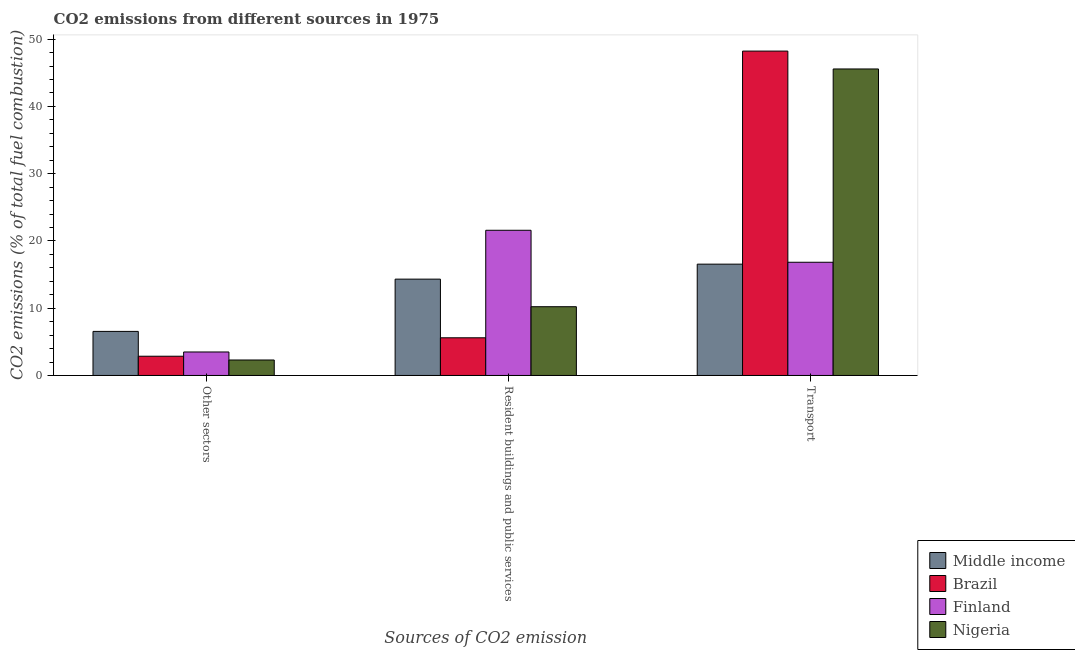How many groups of bars are there?
Provide a succinct answer. 3. How many bars are there on the 2nd tick from the left?
Provide a short and direct response. 4. What is the label of the 2nd group of bars from the left?
Provide a short and direct response. Resident buildings and public services. What is the percentage of co2 emissions from other sectors in Nigeria?
Offer a very short reply. 2.3. Across all countries, what is the maximum percentage of co2 emissions from other sectors?
Your answer should be very brief. 6.55. Across all countries, what is the minimum percentage of co2 emissions from resident buildings and public services?
Provide a succinct answer. 5.6. In which country was the percentage of co2 emissions from transport maximum?
Offer a very short reply. Brazil. In which country was the percentage of co2 emissions from transport minimum?
Your answer should be compact. Middle income. What is the total percentage of co2 emissions from transport in the graph?
Offer a very short reply. 127.18. What is the difference between the percentage of co2 emissions from transport in Finland and that in Nigeria?
Make the answer very short. -28.74. What is the difference between the percentage of co2 emissions from resident buildings and public services in Nigeria and the percentage of co2 emissions from transport in Middle income?
Keep it short and to the point. -6.33. What is the average percentage of co2 emissions from resident buildings and public services per country?
Provide a succinct answer. 12.93. What is the difference between the percentage of co2 emissions from other sectors and percentage of co2 emissions from resident buildings and public services in Middle income?
Your answer should be compact. -7.77. In how many countries, is the percentage of co2 emissions from other sectors greater than 8 %?
Offer a very short reply. 0. What is the ratio of the percentage of co2 emissions from transport in Middle income to that in Brazil?
Offer a very short reply. 0.34. Is the percentage of co2 emissions from resident buildings and public services in Brazil less than that in Nigeria?
Ensure brevity in your answer.  Yes. Is the difference between the percentage of co2 emissions from resident buildings and public services in Middle income and Nigeria greater than the difference between the percentage of co2 emissions from other sectors in Middle income and Nigeria?
Keep it short and to the point. No. What is the difference between the highest and the second highest percentage of co2 emissions from other sectors?
Give a very brief answer. 3.06. What is the difference between the highest and the lowest percentage of co2 emissions from other sectors?
Give a very brief answer. 4.25. In how many countries, is the percentage of co2 emissions from transport greater than the average percentage of co2 emissions from transport taken over all countries?
Make the answer very short. 2. Is the sum of the percentage of co2 emissions from transport in Middle income and Nigeria greater than the maximum percentage of co2 emissions from resident buildings and public services across all countries?
Give a very brief answer. Yes. What does the 4th bar from the left in Resident buildings and public services represents?
Your answer should be very brief. Nigeria. Is it the case that in every country, the sum of the percentage of co2 emissions from other sectors and percentage of co2 emissions from resident buildings and public services is greater than the percentage of co2 emissions from transport?
Your answer should be very brief. No. How many countries are there in the graph?
Keep it short and to the point. 4. What is the difference between two consecutive major ticks on the Y-axis?
Your answer should be very brief. 10. Does the graph contain any zero values?
Your response must be concise. No. Where does the legend appear in the graph?
Provide a short and direct response. Bottom right. How many legend labels are there?
Your response must be concise. 4. What is the title of the graph?
Ensure brevity in your answer.  CO2 emissions from different sources in 1975. Does "Rwanda" appear as one of the legend labels in the graph?
Offer a very short reply. No. What is the label or title of the X-axis?
Your answer should be very brief. Sources of CO2 emission. What is the label or title of the Y-axis?
Make the answer very short. CO2 emissions (% of total fuel combustion). What is the CO2 emissions (% of total fuel combustion) in Middle income in Other sectors?
Offer a very short reply. 6.55. What is the CO2 emissions (% of total fuel combustion) in Brazil in Other sectors?
Make the answer very short. 2.86. What is the CO2 emissions (% of total fuel combustion) in Finland in Other sectors?
Make the answer very short. 3.49. What is the CO2 emissions (% of total fuel combustion) in Nigeria in Other sectors?
Provide a short and direct response. 2.3. What is the CO2 emissions (% of total fuel combustion) in Middle income in Resident buildings and public services?
Ensure brevity in your answer.  14.32. What is the CO2 emissions (% of total fuel combustion) in Brazil in Resident buildings and public services?
Your answer should be very brief. 5.6. What is the CO2 emissions (% of total fuel combustion) of Finland in Resident buildings and public services?
Keep it short and to the point. 21.59. What is the CO2 emissions (% of total fuel combustion) of Nigeria in Resident buildings and public services?
Provide a succinct answer. 10.22. What is the CO2 emissions (% of total fuel combustion) of Middle income in Transport?
Ensure brevity in your answer.  16.55. What is the CO2 emissions (% of total fuel combustion) in Brazil in Transport?
Your answer should be compact. 48.23. What is the CO2 emissions (% of total fuel combustion) in Finland in Transport?
Keep it short and to the point. 16.83. What is the CO2 emissions (% of total fuel combustion) of Nigeria in Transport?
Your answer should be compact. 45.57. Across all Sources of CO2 emission, what is the maximum CO2 emissions (% of total fuel combustion) of Middle income?
Give a very brief answer. 16.55. Across all Sources of CO2 emission, what is the maximum CO2 emissions (% of total fuel combustion) in Brazil?
Your answer should be compact. 48.23. Across all Sources of CO2 emission, what is the maximum CO2 emissions (% of total fuel combustion) in Finland?
Offer a very short reply. 21.59. Across all Sources of CO2 emission, what is the maximum CO2 emissions (% of total fuel combustion) of Nigeria?
Give a very brief answer. 45.57. Across all Sources of CO2 emission, what is the minimum CO2 emissions (% of total fuel combustion) of Middle income?
Your response must be concise. 6.55. Across all Sources of CO2 emission, what is the minimum CO2 emissions (% of total fuel combustion) in Brazil?
Keep it short and to the point. 2.86. Across all Sources of CO2 emission, what is the minimum CO2 emissions (% of total fuel combustion) in Finland?
Ensure brevity in your answer.  3.49. Across all Sources of CO2 emission, what is the minimum CO2 emissions (% of total fuel combustion) of Nigeria?
Your answer should be very brief. 2.3. What is the total CO2 emissions (% of total fuel combustion) in Middle income in the graph?
Provide a short and direct response. 37.42. What is the total CO2 emissions (% of total fuel combustion) of Brazil in the graph?
Ensure brevity in your answer.  56.69. What is the total CO2 emissions (% of total fuel combustion) of Finland in the graph?
Offer a very short reply. 41.91. What is the total CO2 emissions (% of total fuel combustion) of Nigeria in the graph?
Provide a succinct answer. 58.09. What is the difference between the CO2 emissions (% of total fuel combustion) in Middle income in Other sectors and that in Resident buildings and public services?
Keep it short and to the point. -7.77. What is the difference between the CO2 emissions (% of total fuel combustion) in Brazil in Other sectors and that in Resident buildings and public services?
Make the answer very short. -2.74. What is the difference between the CO2 emissions (% of total fuel combustion) of Finland in Other sectors and that in Resident buildings and public services?
Keep it short and to the point. -18.09. What is the difference between the CO2 emissions (% of total fuel combustion) of Nigeria in Other sectors and that in Resident buildings and public services?
Your answer should be compact. -7.92. What is the difference between the CO2 emissions (% of total fuel combustion) of Middle income in Other sectors and that in Transport?
Offer a terse response. -10. What is the difference between the CO2 emissions (% of total fuel combustion) in Brazil in Other sectors and that in Transport?
Offer a terse response. -45.37. What is the difference between the CO2 emissions (% of total fuel combustion) of Finland in Other sectors and that in Transport?
Your answer should be very brief. -13.34. What is the difference between the CO2 emissions (% of total fuel combustion) in Nigeria in Other sectors and that in Transport?
Provide a short and direct response. -43.27. What is the difference between the CO2 emissions (% of total fuel combustion) in Middle income in Resident buildings and public services and that in Transport?
Keep it short and to the point. -2.23. What is the difference between the CO2 emissions (% of total fuel combustion) in Brazil in Resident buildings and public services and that in Transport?
Provide a short and direct response. -42.63. What is the difference between the CO2 emissions (% of total fuel combustion) of Finland in Resident buildings and public services and that in Transport?
Give a very brief answer. 4.75. What is the difference between the CO2 emissions (% of total fuel combustion) of Nigeria in Resident buildings and public services and that in Transport?
Keep it short and to the point. -35.35. What is the difference between the CO2 emissions (% of total fuel combustion) of Middle income in Other sectors and the CO2 emissions (% of total fuel combustion) of Brazil in Resident buildings and public services?
Make the answer very short. 0.95. What is the difference between the CO2 emissions (% of total fuel combustion) of Middle income in Other sectors and the CO2 emissions (% of total fuel combustion) of Finland in Resident buildings and public services?
Provide a succinct answer. -15.04. What is the difference between the CO2 emissions (% of total fuel combustion) in Middle income in Other sectors and the CO2 emissions (% of total fuel combustion) in Nigeria in Resident buildings and public services?
Give a very brief answer. -3.67. What is the difference between the CO2 emissions (% of total fuel combustion) in Brazil in Other sectors and the CO2 emissions (% of total fuel combustion) in Finland in Resident buildings and public services?
Your answer should be compact. -18.73. What is the difference between the CO2 emissions (% of total fuel combustion) of Brazil in Other sectors and the CO2 emissions (% of total fuel combustion) of Nigeria in Resident buildings and public services?
Your answer should be very brief. -7.36. What is the difference between the CO2 emissions (% of total fuel combustion) of Finland in Other sectors and the CO2 emissions (% of total fuel combustion) of Nigeria in Resident buildings and public services?
Provide a succinct answer. -6.73. What is the difference between the CO2 emissions (% of total fuel combustion) in Middle income in Other sectors and the CO2 emissions (% of total fuel combustion) in Brazil in Transport?
Your answer should be compact. -41.68. What is the difference between the CO2 emissions (% of total fuel combustion) of Middle income in Other sectors and the CO2 emissions (% of total fuel combustion) of Finland in Transport?
Offer a very short reply. -10.28. What is the difference between the CO2 emissions (% of total fuel combustion) in Middle income in Other sectors and the CO2 emissions (% of total fuel combustion) in Nigeria in Transport?
Keep it short and to the point. -39.02. What is the difference between the CO2 emissions (% of total fuel combustion) of Brazil in Other sectors and the CO2 emissions (% of total fuel combustion) of Finland in Transport?
Ensure brevity in your answer.  -13.97. What is the difference between the CO2 emissions (% of total fuel combustion) in Brazil in Other sectors and the CO2 emissions (% of total fuel combustion) in Nigeria in Transport?
Your answer should be very brief. -42.71. What is the difference between the CO2 emissions (% of total fuel combustion) in Finland in Other sectors and the CO2 emissions (% of total fuel combustion) in Nigeria in Transport?
Make the answer very short. -42.08. What is the difference between the CO2 emissions (% of total fuel combustion) of Middle income in Resident buildings and public services and the CO2 emissions (% of total fuel combustion) of Brazil in Transport?
Your answer should be compact. -33.9. What is the difference between the CO2 emissions (% of total fuel combustion) of Middle income in Resident buildings and public services and the CO2 emissions (% of total fuel combustion) of Finland in Transport?
Your response must be concise. -2.51. What is the difference between the CO2 emissions (% of total fuel combustion) of Middle income in Resident buildings and public services and the CO2 emissions (% of total fuel combustion) of Nigeria in Transport?
Provide a short and direct response. -31.25. What is the difference between the CO2 emissions (% of total fuel combustion) in Brazil in Resident buildings and public services and the CO2 emissions (% of total fuel combustion) in Finland in Transport?
Ensure brevity in your answer.  -11.23. What is the difference between the CO2 emissions (% of total fuel combustion) in Brazil in Resident buildings and public services and the CO2 emissions (% of total fuel combustion) in Nigeria in Transport?
Your answer should be very brief. -39.97. What is the difference between the CO2 emissions (% of total fuel combustion) of Finland in Resident buildings and public services and the CO2 emissions (% of total fuel combustion) of Nigeria in Transport?
Give a very brief answer. -23.98. What is the average CO2 emissions (% of total fuel combustion) of Middle income per Sources of CO2 emission?
Your answer should be very brief. 12.47. What is the average CO2 emissions (% of total fuel combustion) in Brazil per Sources of CO2 emission?
Offer a terse response. 18.9. What is the average CO2 emissions (% of total fuel combustion) of Finland per Sources of CO2 emission?
Provide a short and direct response. 13.97. What is the average CO2 emissions (% of total fuel combustion) of Nigeria per Sources of CO2 emission?
Make the answer very short. 19.36. What is the difference between the CO2 emissions (% of total fuel combustion) in Middle income and CO2 emissions (% of total fuel combustion) in Brazil in Other sectors?
Ensure brevity in your answer.  3.69. What is the difference between the CO2 emissions (% of total fuel combustion) of Middle income and CO2 emissions (% of total fuel combustion) of Finland in Other sectors?
Keep it short and to the point. 3.06. What is the difference between the CO2 emissions (% of total fuel combustion) of Middle income and CO2 emissions (% of total fuel combustion) of Nigeria in Other sectors?
Your answer should be compact. 4.25. What is the difference between the CO2 emissions (% of total fuel combustion) in Brazil and CO2 emissions (% of total fuel combustion) in Finland in Other sectors?
Your response must be concise. -0.63. What is the difference between the CO2 emissions (% of total fuel combustion) of Brazil and CO2 emissions (% of total fuel combustion) of Nigeria in Other sectors?
Offer a very short reply. 0.56. What is the difference between the CO2 emissions (% of total fuel combustion) in Finland and CO2 emissions (% of total fuel combustion) in Nigeria in Other sectors?
Ensure brevity in your answer.  1.19. What is the difference between the CO2 emissions (% of total fuel combustion) in Middle income and CO2 emissions (% of total fuel combustion) in Brazil in Resident buildings and public services?
Ensure brevity in your answer.  8.72. What is the difference between the CO2 emissions (% of total fuel combustion) of Middle income and CO2 emissions (% of total fuel combustion) of Finland in Resident buildings and public services?
Offer a very short reply. -7.26. What is the difference between the CO2 emissions (% of total fuel combustion) in Middle income and CO2 emissions (% of total fuel combustion) in Nigeria in Resident buildings and public services?
Your answer should be compact. 4.1. What is the difference between the CO2 emissions (% of total fuel combustion) in Brazil and CO2 emissions (% of total fuel combustion) in Finland in Resident buildings and public services?
Offer a terse response. -15.98. What is the difference between the CO2 emissions (% of total fuel combustion) of Brazil and CO2 emissions (% of total fuel combustion) of Nigeria in Resident buildings and public services?
Make the answer very short. -4.62. What is the difference between the CO2 emissions (% of total fuel combustion) of Finland and CO2 emissions (% of total fuel combustion) of Nigeria in Resident buildings and public services?
Keep it short and to the point. 11.36. What is the difference between the CO2 emissions (% of total fuel combustion) of Middle income and CO2 emissions (% of total fuel combustion) of Brazil in Transport?
Offer a very short reply. -31.68. What is the difference between the CO2 emissions (% of total fuel combustion) of Middle income and CO2 emissions (% of total fuel combustion) of Finland in Transport?
Your answer should be compact. -0.28. What is the difference between the CO2 emissions (% of total fuel combustion) of Middle income and CO2 emissions (% of total fuel combustion) of Nigeria in Transport?
Offer a terse response. -29.02. What is the difference between the CO2 emissions (% of total fuel combustion) of Brazil and CO2 emissions (% of total fuel combustion) of Finland in Transport?
Your answer should be compact. 31.4. What is the difference between the CO2 emissions (% of total fuel combustion) in Brazil and CO2 emissions (% of total fuel combustion) in Nigeria in Transport?
Provide a succinct answer. 2.66. What is the difference between the CO2 emissions (% of total fuel combustion) in Finland and CO2 emissions (% of total fuel combustion) in Nigeria in Transport?
Keep it short and to the point. -28.74. What is the ratio of the CO2 emissions (% of total fuel combustion) in Middle income in Other sectors to that in Resident buildings and public services?
Your answer should be very brief. 0.46. What is the ratio of the CO2 emissions (% of total fuel combustion) of Brazil in Other sectors to that in Resident buildings and public services?
Offer a terse response. 0.51. What is the ratio of the CO2 emissions (% of total fuel combustion) in Finland in Other sectors to that in Resident buildings and public services?
Ensure brevity in your answer.  0.16. What is the ratio of the CO2 emissions (% of total fuel combustion) of Nigeria in Other sectors to that in Resident buildings and public services?
Provide a succinct answer. 0.23. What is the ratio of the CO2 emissions (% of total fuel combustion) of Middle income in Other sectors to that in Transport?
Provide a short and direct response. 0.4. What is the ratio of the CO2 emissions (% of total fuel combustion) of Brazil in Other sectors to that in Transport?
Give a very brief answer. 0.06. What is the ratio of the CO2 emissions (% of total fuel combustion) in Finland in Other sectors to that in Transport?
Make the answer very short. 0.21. What is the ratio of the CO2 emissions (% of total fuel combustion) in Nigeria in Other sectors to that in Transport?
Provide a succinct answer. 0.05. What is the ratio of the CO2 emissions (% of total fuel combustion) of Middle income in Resident buildings and public services to that in Transport?
Your answer should be compact. 0.87. What is the ratio of the CO2 emissions (% of total fuel combustion) of Brazil in Resident buildings and public services to that in Transport?
Your response must be concise. 0.12. What is the ratio of the CO2 emissions (% of total fuel combustion) in Finland in Resident buildings and public services to that in Transport?
Offer a very short reply. 1.28. What is the ratio of the CO2 emissions (% of total fuel combustion) in Nigeria in Resident buildings and public services to that in Transport?
Ensure brevity in your answer.  0.22. What is the difference between the highest and the second highest CO2 emissions (% of total fuel combustion) in Middle income?
Make the answer very short. 2.23. What is the difference between the highest and the second highest CO2 emissions (% of total fuel combustion) in Brazil?
Offer a very short reply. 42.63. What is the difference between the highest and the second highest CO2 emissions (% of total fuel combustion) of Finland?
Keep it short and to the point. 4.75. What is the difference between the highest and the second highest CO2 emissions (% of total fuel combustion) in Nigeria?
Offer a terse response. 35.35. What is the difference between the highest and the lowest CO2 emissions (% of total fuel combustion) in Middle income?
Ensure brevity in your answer.  10. What is the difference between the highest and the lowest CO2 emissions (% of total fuel combustion) in Brazil?
Provide a short and direct response. 45.37. What is the difference between the highest and the lowest CO2 emissions (% of total fuel combustion) in Finland?
Provide a short and direct response. 18.09. What is the difference between the highest and the lowest CO2 emissions (% of total fuel combustion) of Nigeria?
Ensure brevity in your answer.  43.27. 